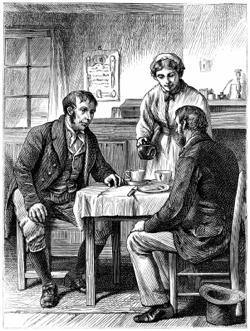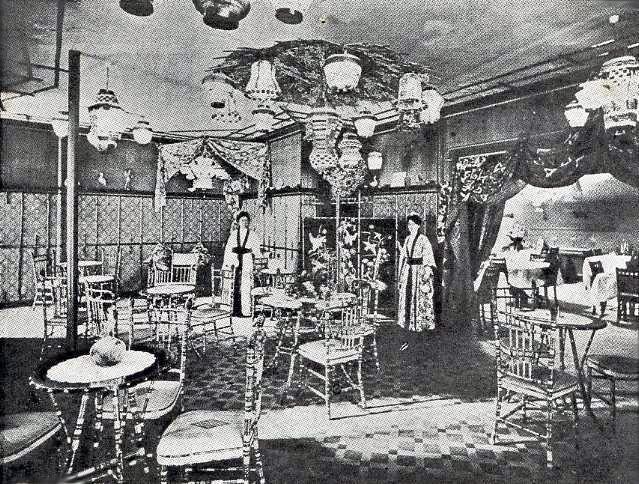The first image is the image on the left, the second image is the image on the right. For the images shown, is this caption "One black and white photo and one sepia photo." true? Answer yes or no. No. The first image is the image on the left, the second image is the image on the right. For the images shown, is this caption "The left image shows two people seated at a small table set with coffee cups, and a person standing behind them." true? Answer yes or no. Yes. 